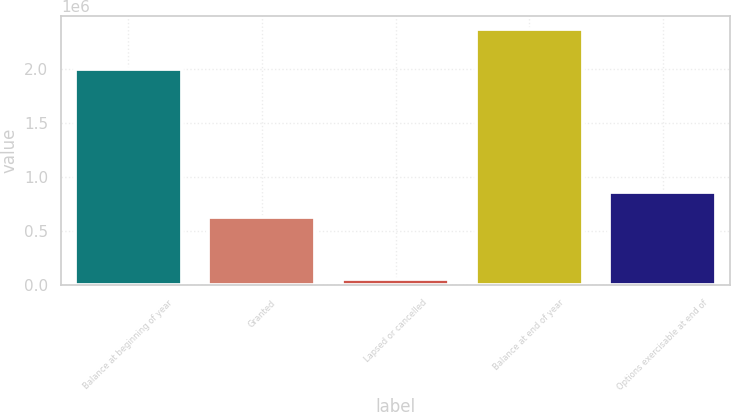Convert chart. <chart><loc_0><loc_0><loc_500><loc_500><bar_chart><fcel>Balance at beginning of year<fcel>Granted<fcel>Lapsed or cancelled<fcel>Balance at end of year<fcel>Options exercisable at end of<nl><fcel>2.00233e+06<fcel>633000<fcel>57479<fcel>2.37182e+06<fcel>864434<nl></chart> 